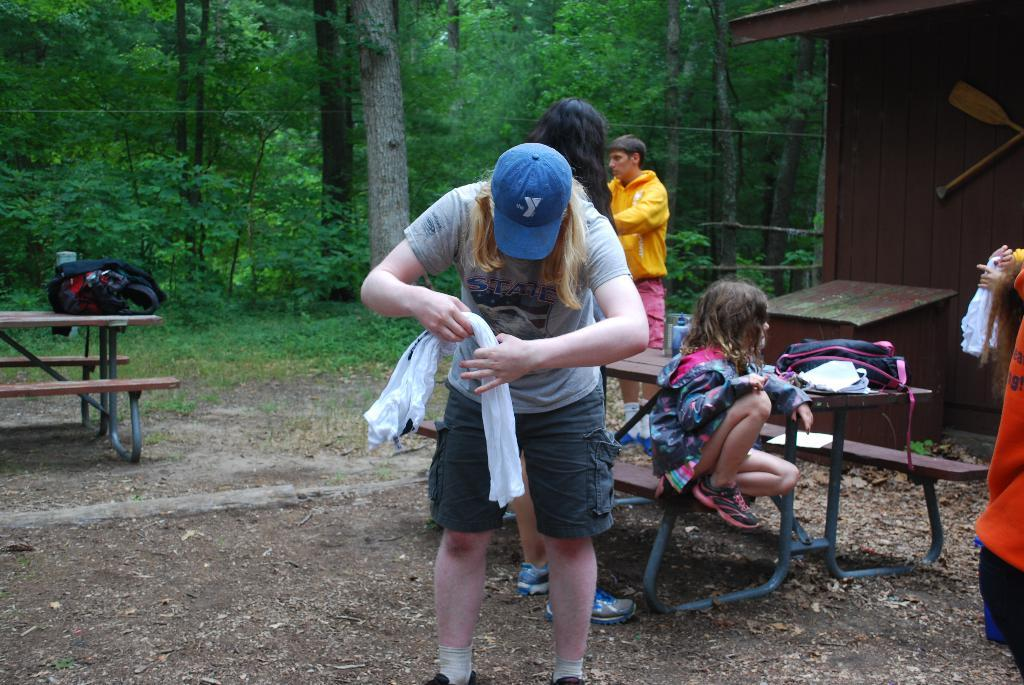Who is the main subject in the image? There is a woman in the image. What is the woman holding in her hand? The woman is holding clothes in her hand. What can be seen in the background of the image? There are trees visible in the background. How many people are present in the image? There are people in the image, including a woman and a kid sitting on a chair. What objects are on the table in the image? There are bags on a table in the image. What type of railway can be seen in the image? There is no railway present in the image. Is the garden visible in the image? There is no garden visible in the image. 